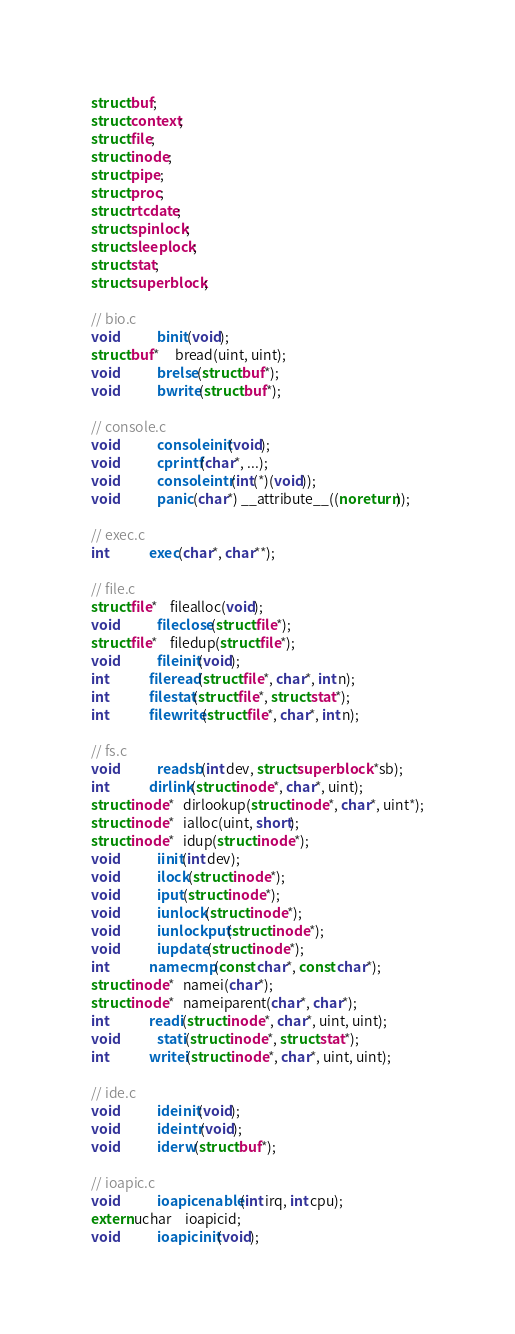Convert code to text. <code><loc_0><loc_0><loc_500><loc_500><_C_>struct buf;
struct context;
struct file;
struct inode;
struct pipe;
struct proc;
struct rtcdate;
struct spinlock;
struct sleeplock;
struct stat;
struct superblock;

// bio.c
void            binit(void);
struct buf*     bread(uint, uint);
void            brelse(struct buf*);
void            bwrite(struct buf*);

// console.c
void            consoleinit(void);
void            cprintf(char*, ...);
void            consoleintr(int(*)(void));
void            panic(char*) __attribute__((noreturn));

// exec.c
int             exec(char*, char**);

// file.c
struct file*    filealloc(void);
void            fileclose(struct file*);
struct file*    filedup(struct file*);
void            fileinit(void);
int             fileread(struct file*, char*, int n);
int             filestat(struct file*, struct stat*);
int             filewrite(struct file*, char*, int n);

// fs.c
void            readsb(int dev, struct superblock *sb);
int             dirlink(struct inode*, char*, uint);
struct inode*   dirlookup(struct inode*, char*, uint*);
struct inode*   ialloc(uint, short);
struct inode*   idup(struct inode*);
void            iinit(int dev);
void            ilock(struct inode*);
void            iput(struct inode*);
void            iunlock(struct inode*);
void            iunlockput(struct inode*);
void            iupdate(struct inode*);
int             namecmp(const char*, const char*);
struct inode*   namei(char*);
struct inode*   nameiparent(char*, char*);
int             readi(struct inode*, char*, uint, uint);
void            stati(struct inode*, struct stat*);
int             writei(struct inode*, char*, uint, uint);

// ide.c
void            ideinit(void);
void            ideintr(void);
void            iderw(struct buf*);

// ioapic.c
void            ioapicenable(int irq, int cpu);
extern uchar    ioapicid;
void            ioapicinit(void);
</code> 